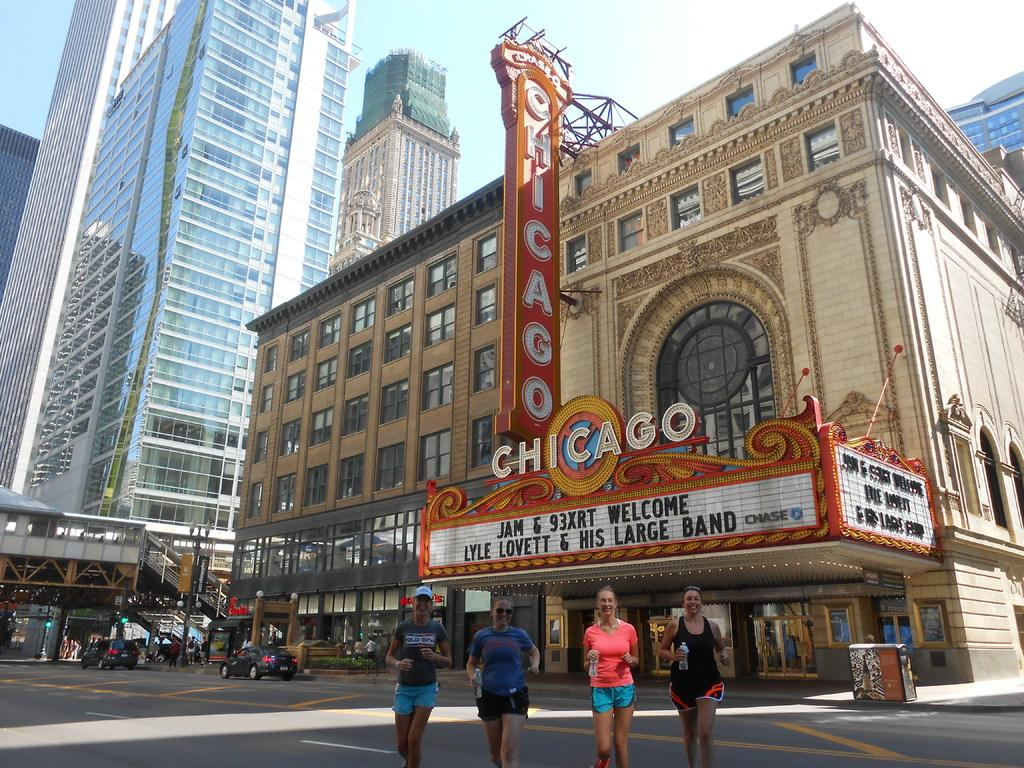What type of structures can be seen in the image? There are buildings in the image. Who or what is located at the bottom of the image? There are people at the bottom of the image. What type of vehicles can be seen on the road? Cars are visible on the road. What is visible in the background of the image? There is sky visible in the background of the image. Can you tell me how many feathers are on the buildings in the image? There are no feathers present on the buildings in the image. What type of stretch is being performed by the people at the bottom of the image? There is no stretch being performed by the people at the bottom of the image; they are simply standing or walking. 